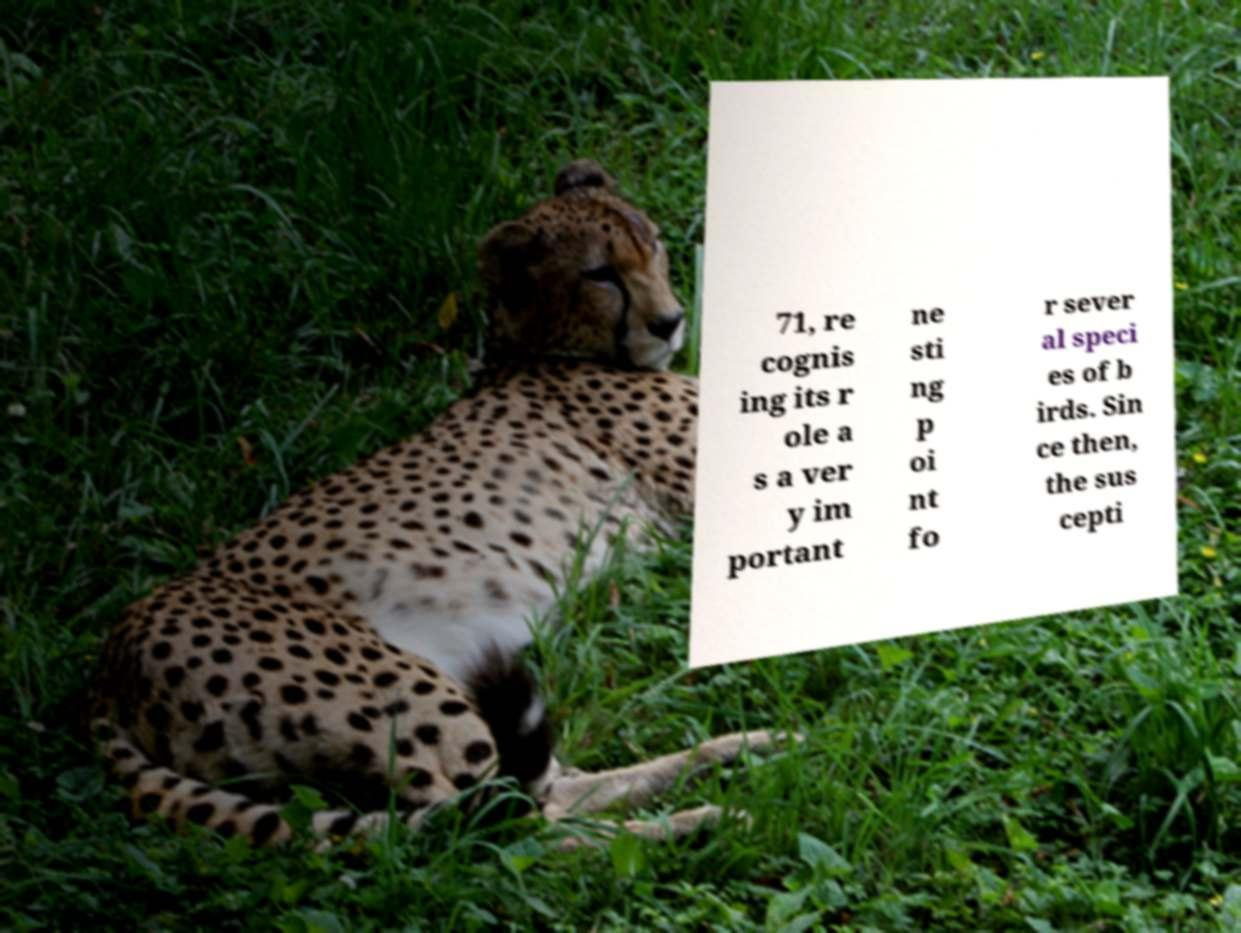Could you extract and type out the text from this image? 71, re cognis ing its r ole a s a ver y im portant ne sti ng p oi nt fo r sever al speci es of b irds. Sin ce then, the sus cepti 